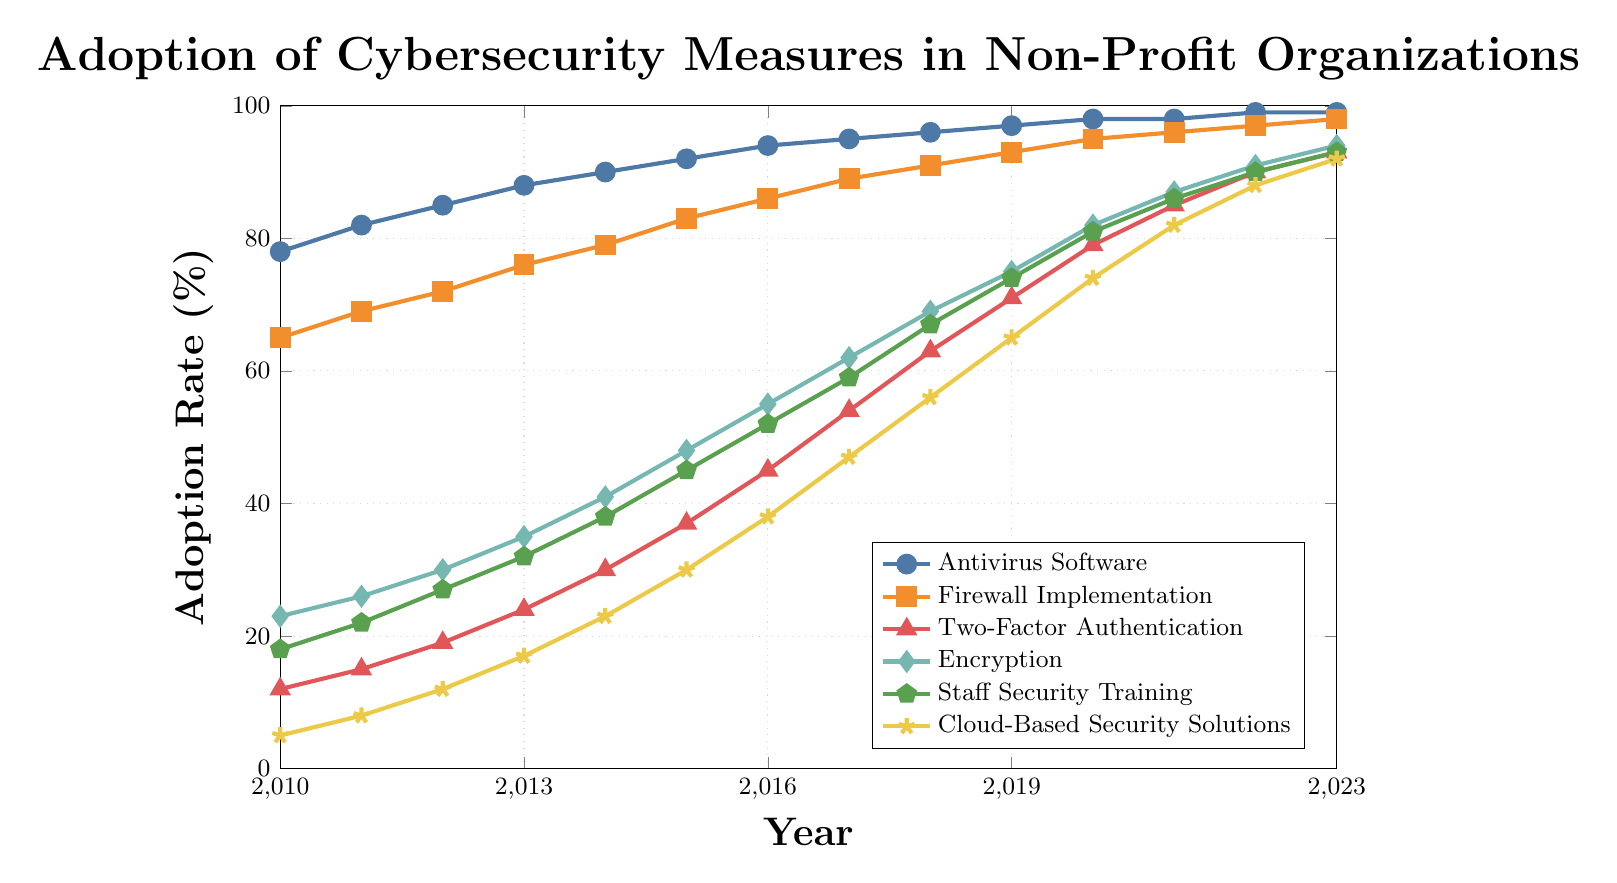What's the trend of Antivirus Software adoption over the years? The adoption rate of Antivirus Software has shown a steady increase over the years. In 2010, it was at 78%, and it gradually climbed up each year, reaching 99% in 2023.
Answer: Increasing trend How much did the adoption rate of Two-Factor Authentication increase from 2010 to 2023? In 2010, the adoption rate of Two-Factor Authentication was 12%. By 2023, it increased to 93%. The difference is 93% - 12% = 81%.
Answer: 81% Which cybersecurity measure showed the highest adoption rate in 2023? Based on the figure, both Antivirus Software and Firewall Implementation have an adoption rate of 99% in 2023.
Answer: Antivirus Software and Firewall Implementation By what percentage did the adoption rate of Cloud-Based Security Solutions increase between 2012 and 2020? In 2012, the adoption rate of Cloud-Based Security Solutions was 12%. In 2020, it was 74%. The difference is 74% - 12% = 62%.
Answer: 62% Which year did Staff Security Training surpass the 50% adoption rate? According to the figure, Staff Security Training crossed the 50% mark in the year 2016, with an adoption rate of 52%.
Answer: 2016 Compare the adoption rates of Encryption and Cloud-Based Security Solutions in 2015. Which was higher and by how much? In 2015, the adoption rate of Encryption was 48%, and Cloud-Based Security Solutions was 30%. The difference is 48% - 30% = 18%. So, Encryption had a higher adoption rate by 18%.
Answer: Encryption by 18% What is the average adoption rate of Firewall Implementation between 2010 and 2023? To find the average, add all the yearly adoption rates of Firewall Implementation and divide by the number of years: (65+69+72+76+79+83+86+89+91+93+95+96+97+98) / 14 = 83%.
Answer: 83% In which year did the adoption rate of Two-Factor Authentication first exceed 50%? The figure indicates that Two-Factor Authentication exceeded 50% adoption in 2017, reaching 54%.
Answer: 2017 Which cybersecurity measure had the lowest adoption rate in 2013, and what was the rate? In 2013, Two-Factor Authentication had the lowest adoption rate at 24%.
Answer: Two-Factor Authentication, 24% How did the adoption rate of Staff Security Training change from 2019 to 2020? The adoption rate of Staff Security Training increased from 74% in 2019 to 81% in 2020. The difference is 81% - 74% = 7%.
Answer: Increased by 7% 